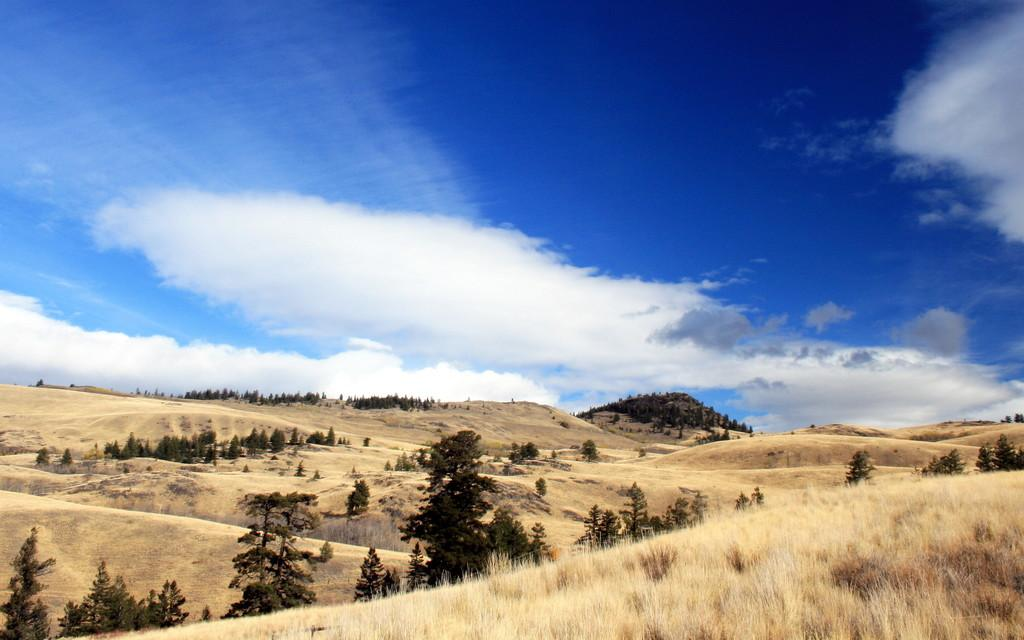What type of vegetation is present in the image? There is grass in the image. What other natural elements can be seen in the image? There are trees in the image. What kind of landscape feature is visible in the image? There is a hill in the image. What is visible in the background of the image? The sky is visible in the image. Can you see any bees buzzing around the grass in the image? There is no indication of bees or any other insects in the image. Is there a cub visible in the image? There is no cub present in the image. What type of medical facility can be seen in the image? There is no hospital or any medical facility present in the image. 